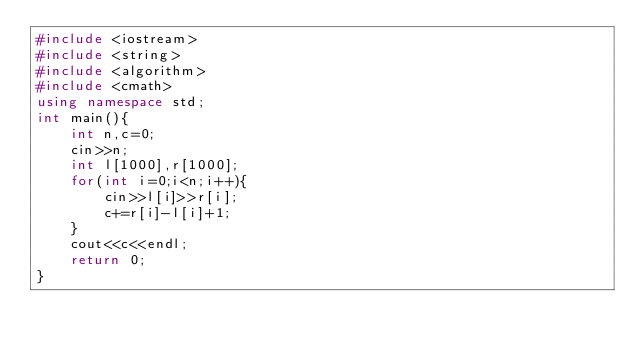<code> <loc_0><loc_0><loc_500><loc_500><_C++_>#include <iostream>
#include <string>
#include <algorithm>
#include <cmath>
using namespace std;
int main(){
	int n,c=0;
	cin>>n;
	int l[1000],r[1000];
	for(int i=0;i<n;i++){
		cin>>l[i]>>r[i];
		c+=r[i]-l[i]+1;
	}
	cout<<c<<endl;
	return 0;
}
</code> 